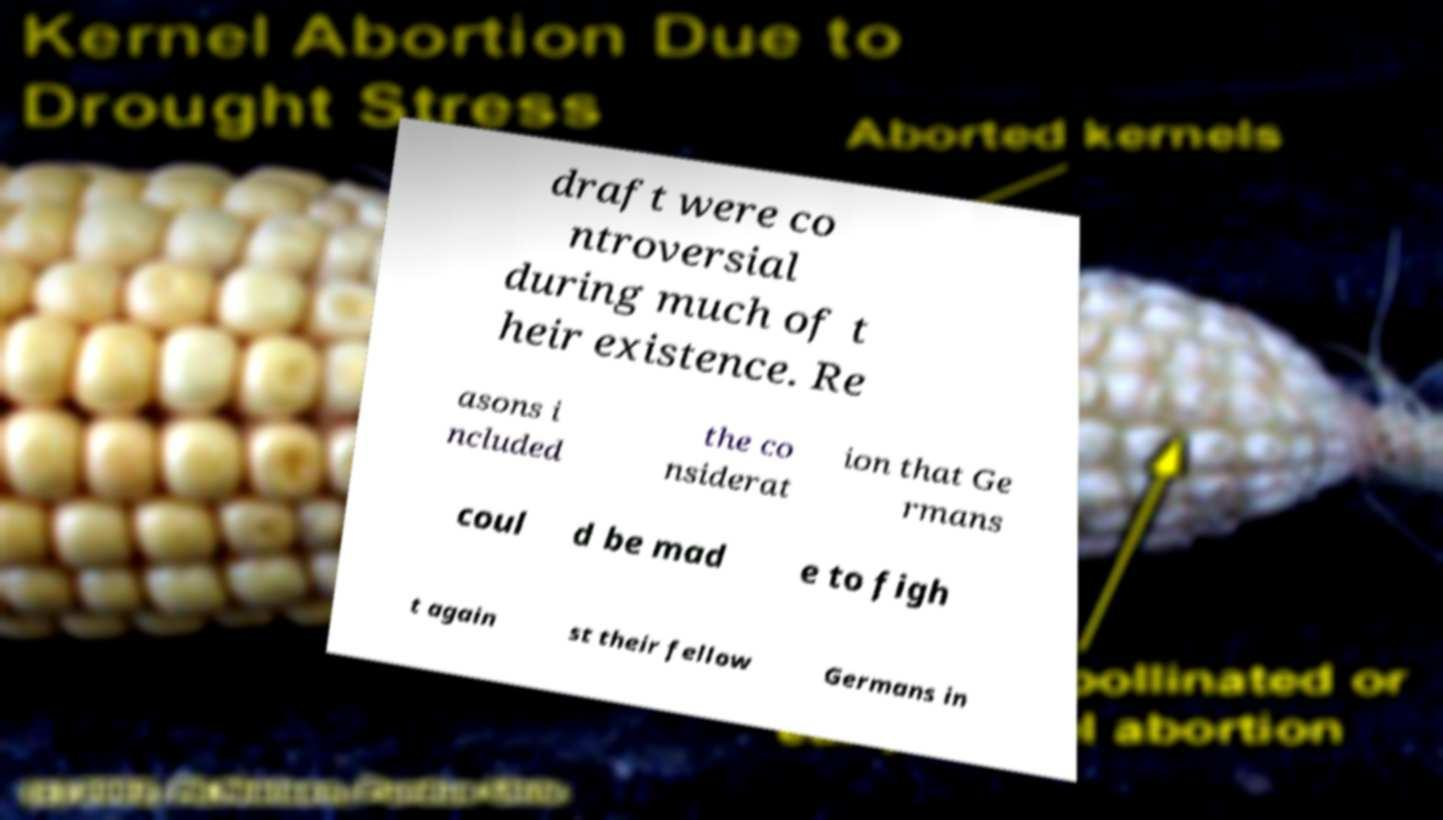What messages or text are displayed in this image? I need them in a readable, typed format. draft were co ntroversial during much of t heir existence. Re asons i ncluded the co nsiderat ion that Ge rmans coul d be mad e to figh t again st their fellow Germans in 